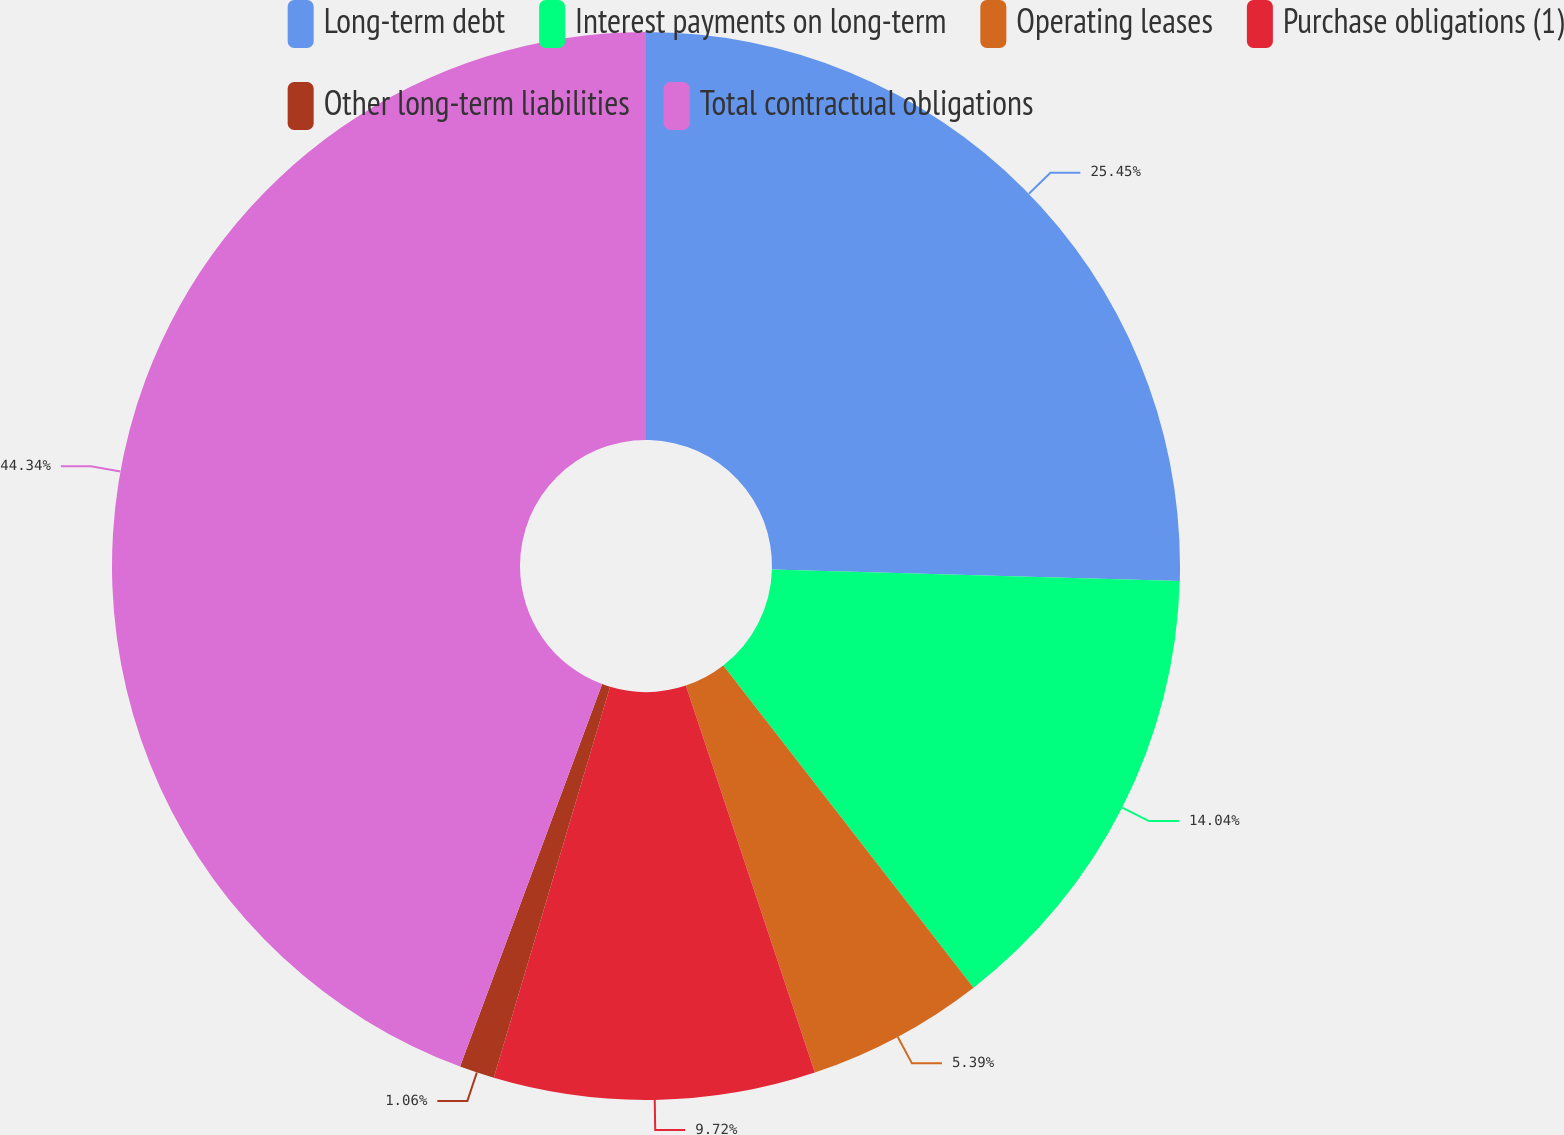<chart> <loc_0><loc_0><loc_500><loc_500><pie_chart><fcel>Long-term debt<fcel>Interest payments on long-term<fcel>Operating leases<fcel>Purchase obligations (1)<fcel>Other long-term liabilities<fcel>Total contractual obligations<nl><fcel>25.45%<fcel>14.04%<fcel>5.39%<fcel>9.72%<fcel>1.06%<fcel>44.34%<nl></chart> 